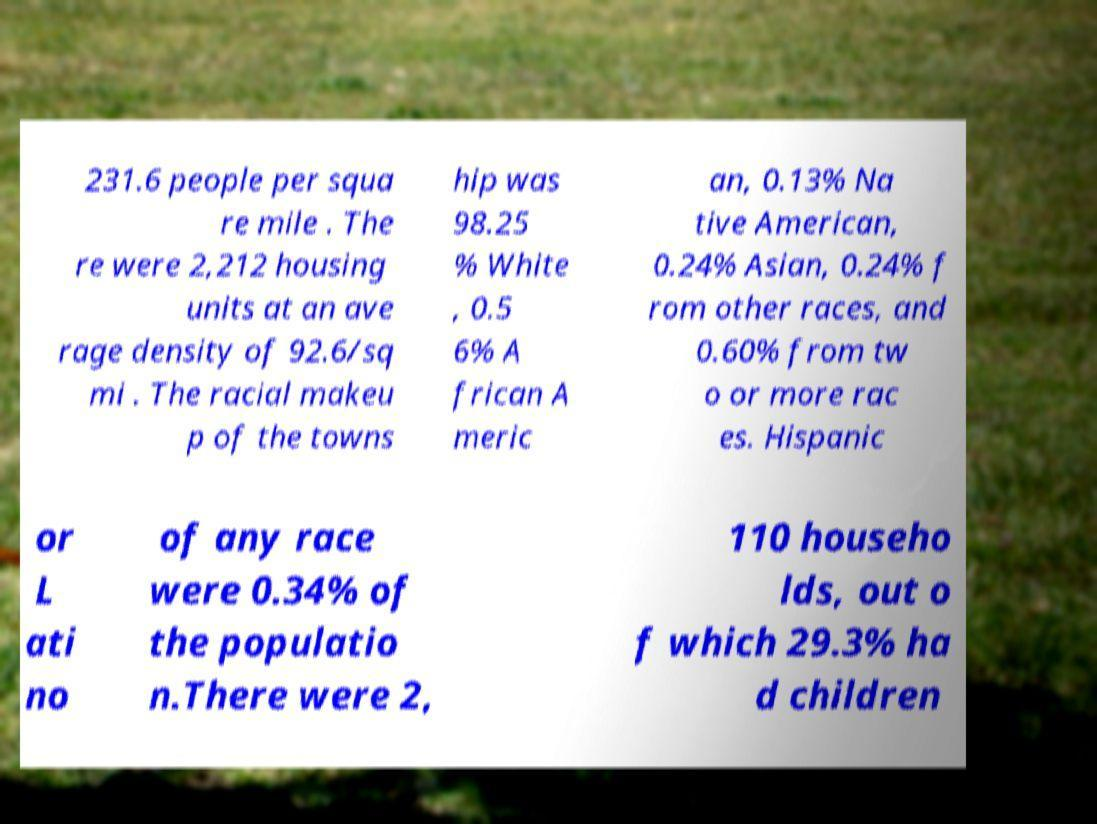Could you extract and type out the text from this image? 231.6 people per squa re mile . The re were 2,212 housing units at an ave rage density of 92.6/sq mi . The racial makeu p of the towns hip was 98.25 % White , 0.5 6% A frican A meric an, 0.13% Na tive American, 0.24% Asian, 0.24% f rom other races, and 0.60% from tw o or more rac es. Hispanic or L ati no of any race were 0.34% of the populatio n.There were 2, 110 househo lds, out o f which 29.3% ha d children 